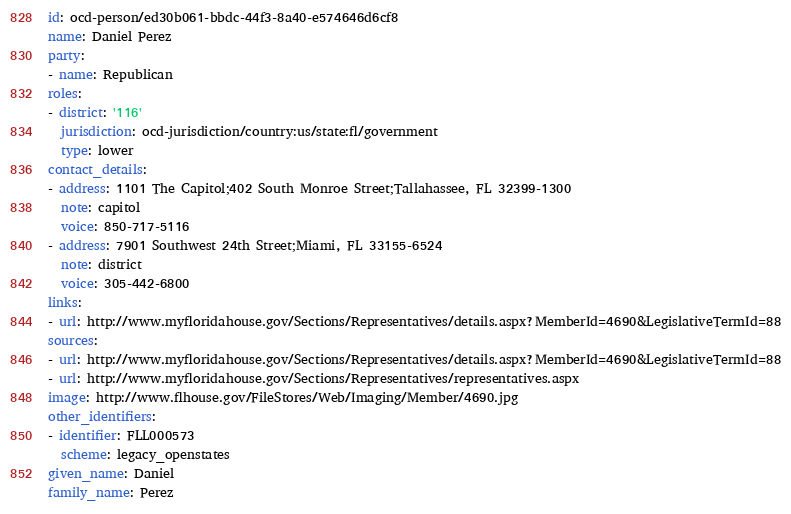Convert code to text. <code><loc_0><loc_0><loc_500><loc_500><_YAML_>id: ocd-person/ed30b061-bbdc-44f3-8a40-e574646d6cf8
name: Daniel Perez
party:
- name: Republican
roles:
- district: '116'
  jurisdiction: ocd-jurisdiction/country:us/state:fl/government
  type: lower
contact_details:
- address: 1101 The Capitol;402 South Monroe Street;Tallahassee, FL 32399-1300
  note: capitol
  voice: 850-717-5116
- address: 7901 Southwest 24th Street;Miami, FL 33155-6524
  note: district
  voice: 305-442-6800
links:
- url: http://www.myfloridahouse.gov/Sections/Representatives/details.aspx?MemberId=4690&LegislativeTermId=88
sources:
- url: http://www.myfloridahouse.gov/Sections/Representatives/details.aspx?MemberId=4690&LegislativeTermId=88
- url: http://www.myfloridahouse.gov/Sections/Representatives/representatives.aspx
image: http://www.flhouse.gov/FileStores/Web/Imaging/Member/4690.jpg
other_identifiers:
- identifier: FLL000573
  scheme: legacy_openstates
given_name: Daniel
family_name: Perez
</code> 